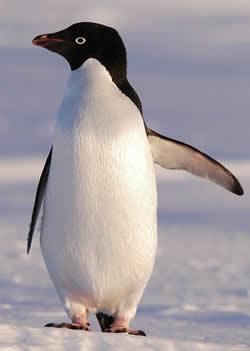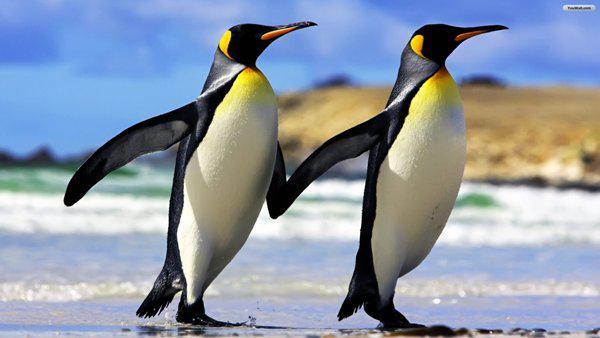The first image is the image on the left, the second image is the image on the right. Evaluate the accuracy of this statement regarding the images: "There are two penguins in the right image.". Is it true? Answer yes or no. Yes. The first image is the image on the left, the second image is the image on the right. Considering the images on both sides, is "An image shows exactly two penguins who appear to be walking """"hand-in-hand""""." valid? Answer yes or no. Yes. 